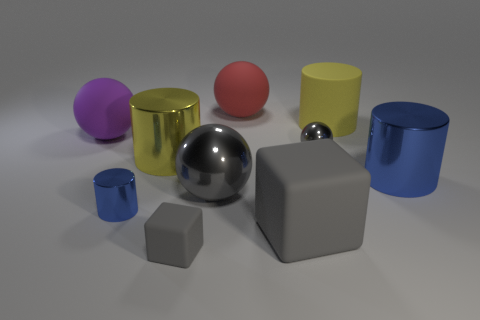Subtract all tiny cylinders. How many cylinders are left? 3 Subtract all blue cylinders. How many cylinders are left? 2 Subtract all cubes. How many objects are left? 8 Subtract 4 cylinders. How many cylinders are left? 0 Add 8 matte cylinders. How many matte cylinders exist? 9 Subtract 0 green cubes. How many objects are left? 10 Subtract all blue cubes. Subtract all red balls. How many cubes are left? 2 Subtract all yellow cylinders. How many gray balls are left? 2 Subtract all small gray spheres. Subtract all cyan blocks. How many objects are left? 9 Add 4 gray spheres. How many gray spheres are left? 6 